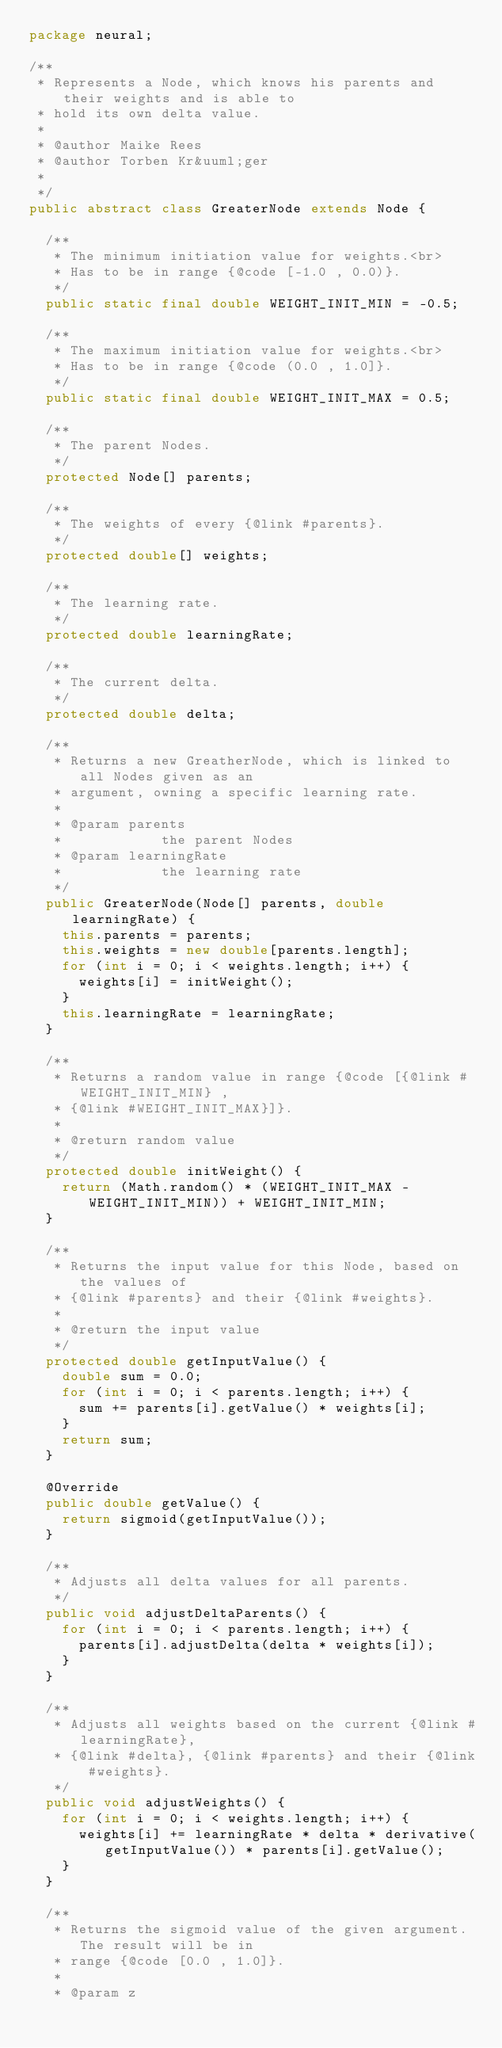Convert code to text. <code><loc_0><loc_0><loc_500><loc_500><_Java_>package neural;

/**
 * Represents a Node, which knows his parents and their weights and is able to
 * hold its own delta value.
 * 
 * @author Maike Rees
 * @author Torben Kr&uuml;ger
 *
 */
public abstract class GreaterNode extends Node {

	/**
	 * The minimum initiation value for weights.<br>
	 * Has to be in range {@code [-1.0 , 0.0)}.
	 */
	public static final double WEIGHT_INIT_MIN = -0.5;

	/**
	 * The maximum initiation value for weights.<br>
	 * Has to be in range {@code (0.0 , 1.0]}.
	 */
	public static final double WEIGHT_INIT_MAX = 0.5;

	/**
	 * The parent Nodes.
	 */
	protected Node[] parents;

	/**
	 * The weights of every {@link #parents}.
	 */
	protected double[] weights;

	/**
	 * The learning rate.
	 */
	protected double learningRate;

	/**
	 * The current delta.
	 */
	protected double delta;

	/**
	 * Returns a new GreatherNode, which is linked to all Nodes given as an
	 * argument, owning a specific learning rate.
	 * 
	 * @param parents
	 *            the parent Nodes
	 * @param learningRate
	 *            the learning rate
	 */
	public GreaterNode(Node[] parents, double learningRate) {
		this.parents = parents;
		this.weights = new double[parents.length];
		for (int i = 0; i < weights.length; i++) {
			weights[i] = initWeight();
		}
		this.learningRate = learningRate;
	}

	/**
	 * Returns a random value in range {@code [{@link #WEIGHT_INIT_MIN} ,
	 * {@link #WEIGHT_INIT_MAX}]}.
	 * 
	 * @return random value
	 */
	protected double initWeight() {
		return (Math.random() * (WEIGHT_INIT_MAX - WEIGHT_INIT_MIN)) + WEIGHT_INIT_MIN;
	}

	/**
	 * Returns the input value for this Node, based on the values of
	 * {@link #parents} and their {@link #weights}.
	 * 
	 * @return the input value
	 */
	protected double getInputValue() {
		double sum = 0.0;
		for (int i = 0; i < parents.length; i++) {
			sum += parents[i].getValue() * weights[i];
		}
		return sum;
	}

	@Override
	public double getValue() {
		return sigmoid(getInputValue());
	}

	/**
	 * Adjusts all delta values for all parents.
	 */
	public void adjustDeltaParents() {
		for (int i = 0; i < parents.length; i++) {
			parents[i].adjustDelta(delta * weights[i]);
		}
	}

	/**
	 * Adjusts all weights based on the current {@link #learningRate},
	 * {@link #delta}, {@link #parents} and their {@link #weights}.
	 */
	public void adjustWeights() {
		for (int i = 0; i < weights.length; i++) {
			weights[i] += learningRate * delta * derivative(getInputValue()) * parents[i].getValue();
		}
	}

	/**
	 * Returns the sigmoid value of the given argument. The result will be in
	 * range {@code [0.0 , 1.0]}.
	 * 
	 * @param z</code> 